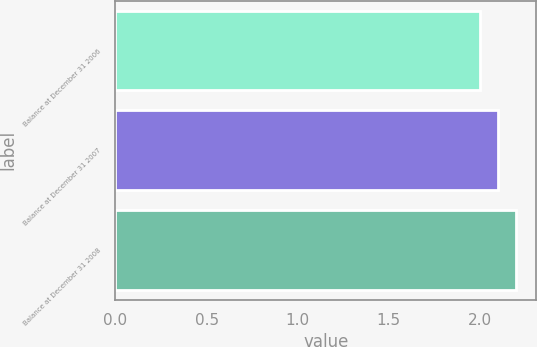Convert chart to OTSL. <chart><loc_0><loc_0><loc_500><loc_500><bar_chart><fcel>Balance at December 31 2006<fcel>Balance at December 31 2007<fcel>Balance at December 31 2008<nl><fcel>2<fcel>2.1<fcel>2.2<nl></chart> 